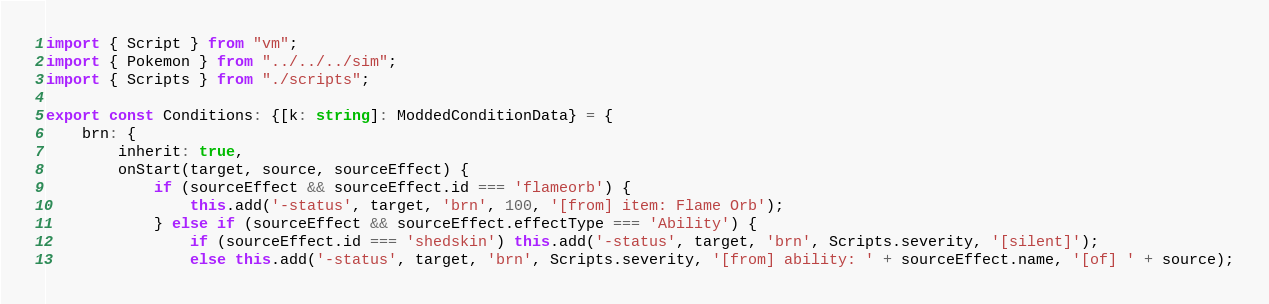Convert code to text. <code><loc_0><loc_0><loc_500><loc_500><_TypeScript_>import { Script } from "vm";
import { Pokemon } from "../../../sim";
import { Scripts } from "./scripts";

export const Conditions: {[k: string]: ModdedConditionData} = {
	brn: {
		inherit: true,
		onStart(target, source, sourceEffect) {
			if (sourceEffect && sourceEffect.id === 'flameorb') {
				this.add('-status', target, 'brn', 100, '[from] item: Flame Orb');
			} else if (sourceEffect && sourceEffect.effectType === 'Ability') {
				if (sourceEffect.id === 'shedskin') this.add('-status', target, 'brn', Scripts.severity, '[silent]');
				else this.add('-status', target, 'brn', Scripts.severity, '[from] ability: ' + sourceEffect.name, '[of] ' + source);</code> 